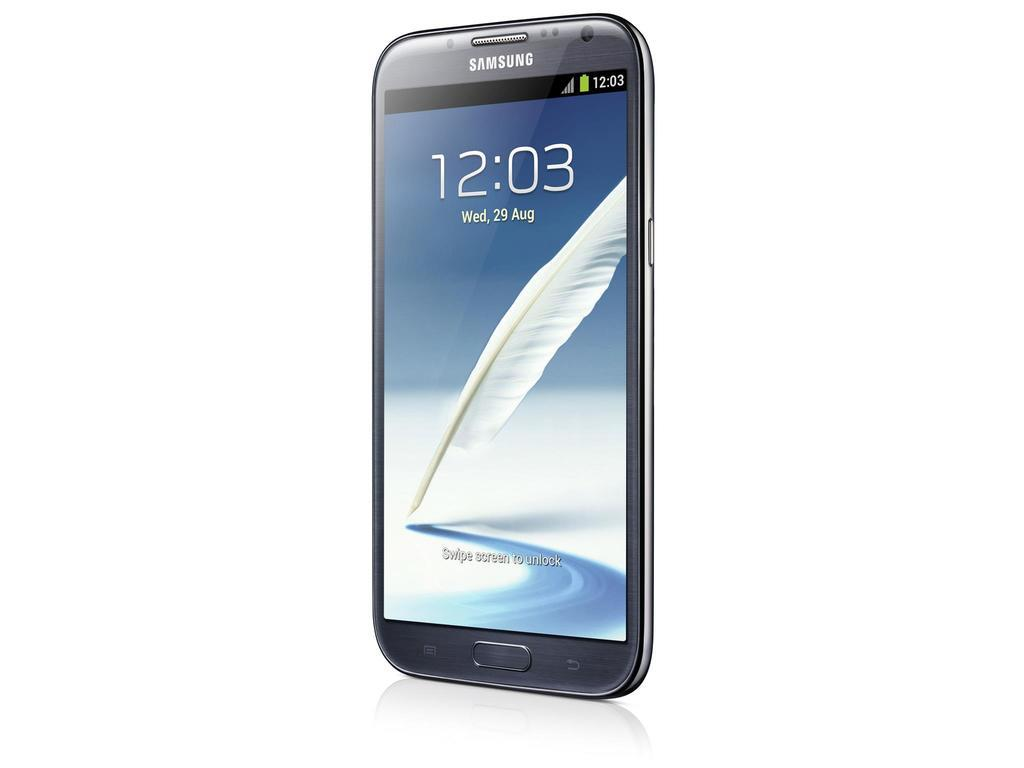<image>
Present a compact description of the photo's key features. A Samsung smart phone shows that on Wednesday, August 29 the time is 12:03 